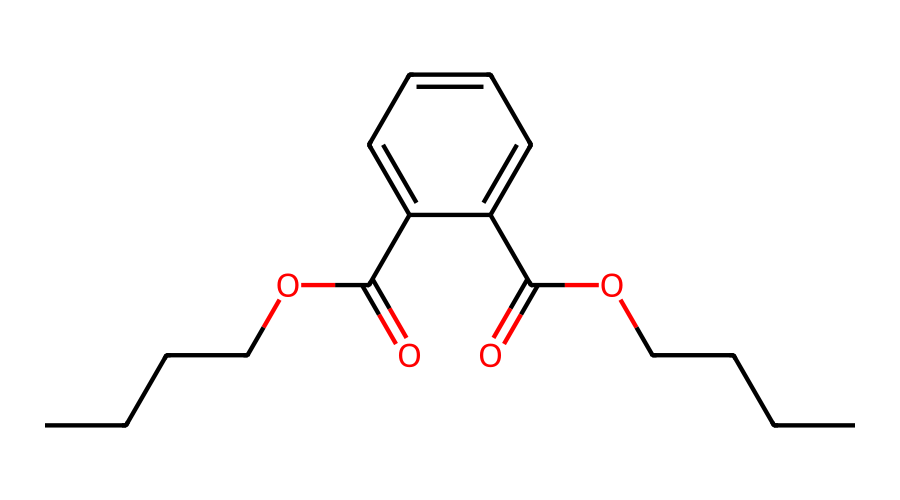what is the total number of carbon atoms in the structure? By analyzing the SMILES representation, we can identify the carbon atoms represented in both the aromatic ring (c1ccccc1) which contributes 6 carbon atoms, and the aliphatic chains (OCCCC) which contribute 4 more carbon atoms in each of the two carboxylic acid groups. Therefore, the total number of carbon atoms can be summed to yield a total of 14 carbon atoms.
Answer: 14 how many oxygen atoms are present in this compound? The SMILES representation indicates the presence of two carboxylic acid groups (O=C(O...) and ...C(=O)O) which each contribute 2 oxygen atoms. Thus, there are a total of 4 oxygen atoms in the entire molecular structure.
Answer: 4 what type of functional groups are featured in this molecule? By examining the SMILES notation, we see the presence of two carboxylic acid groups (indicated by C(=O)O). Hence, the functional groups identified here are carboxylic acids.
Answer: carboxylic acids how does the structure relate to its toxicity? This compound, which is a type of phthalate, contains a combination of ester and aromatic functional groups contributing to its chemical stability and potential endocrine-disrupting properties. This aromatic structure along with the long alkyl chains can lead to bioaccumulation and toxicity within biological systems.
Answer: endocrine disruptor what is the primary use of this chemical in metro stations? Given that this chemical is a phthalate, it is primarily used as a plasticizer, making vinyl flooring more flexible and durable in metro stations to withstand high foot traffic and moisture exposure.
Answer: plasticizer 